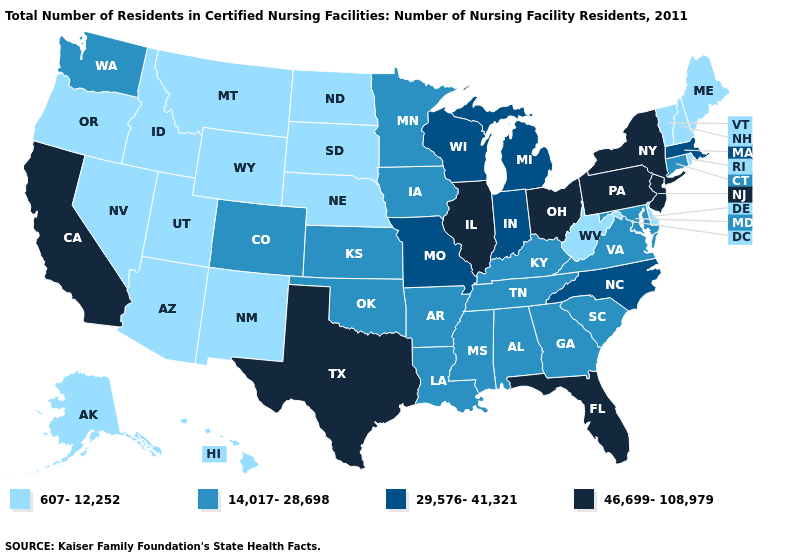Is the legend a continuous bar?
Write a very short answer. No. Name the states that have a value in the range 46,699-108,979?
Be succinct. California, Florida, Illinois, New Jersey, New York, Ohio, Pennsylvania, Texas. Which states have the lowest value in the West?
Be succinct. Alaska, Arizona, Hawaii, Idaho, Montana, Nevada, New Mexico, Oregon, Utah, Wyoming. Does Massachusetts have the lowest value in the USA?
Quick response, please. No. Does Michigan have the lowest value in the USA?
Write a very short answer. No. Name the states that have a value in the range 29,576-41,321?
Write a very short answer. Indiana, Massachusetts, Michigan, Missouri, North Carolina, Wisconsin. Does Nebraska have the same value as Maine?
Answer briefly. Yes. Does West Virginia have the lowest value in the South?
Short answer required. Yes. Is the legend a continuous bar?
Concise answer only. No. What is the value of Missouri?
Short answer required. 29,576-41,321. Name the states that have a value in the range 607-12,252?
Short answer required. Alaska, Arizona, Delaware, Hawaii, Idaho, Maine, Montana, Nebraska, Nevada, New Hampshire, New Mexico, North Dakota, Oregon, Rhode Island, South Dakota, Utah, Vermont, West Virginia, Wyoming. What is the value of Michigan?
Give a very brief answer. 29,576-41,321. Does the map have missing data?
Short answer required. No. Name the states that have a value in the range 29,576-41,321?
Short answer required. Indiana, Massachusetts, Michigan, Missouri, North Carolina, Wisconsin. Does Vermont have a higher value than Arizona?
Answer briefly. No. 